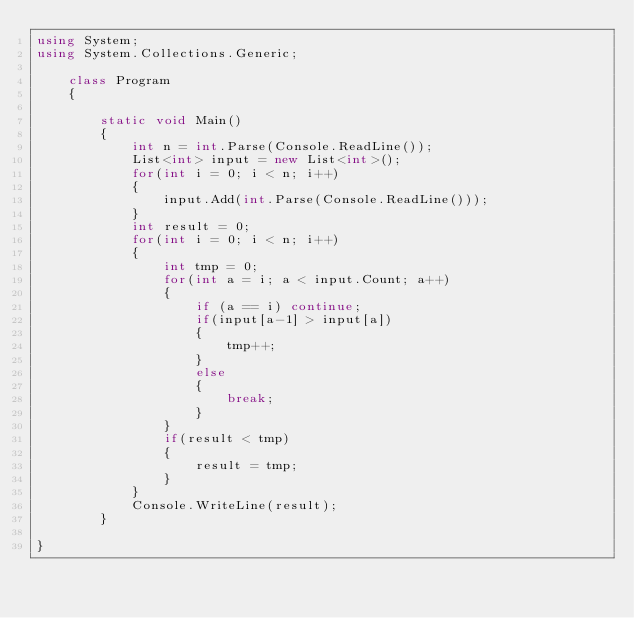Convert code to text. <code><loc_0><loc_0><loc_500><loc_500><_C#_>using System;
using System.Collections.Generic;

    class Program
    {

        static void Main()
        {
            int n = int.Parse(Console.ReadLine());
            List<int> input = new List<int>();
            for(int i = 0; i < n; i++)
            {
                input.Add(int.Parse(Console.ReadLine()));
            }
            int result = 0;
            for(int i = 0; i < n; i++)
            {
                int tmp = 0;
                for(int a = i; a < input.Count; a++)
                {
                    if (a == i) continue;
                    if(input[a-1] > input[a])
                    {
                        tmp++;
                    }
                    else
                    {
                        break;
                    }
                }
                if(result < tmp)
                {
                    result = tmp;
                }
            }
            Console.WriteLine(result);
        }
    
}
</code> 